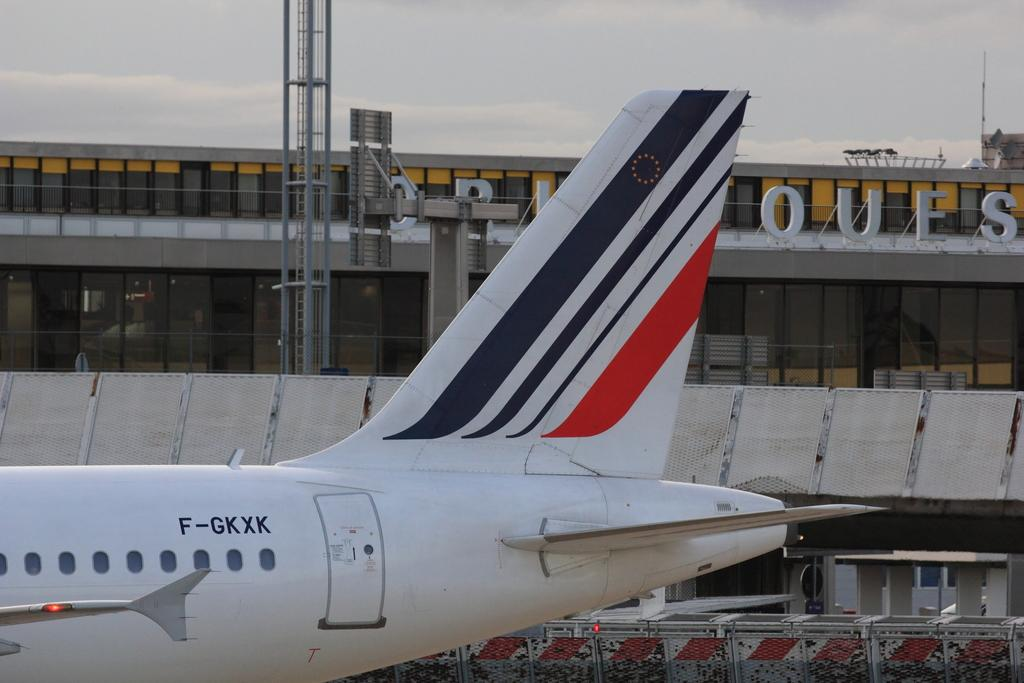What type of location might the image have been taken at? The image might have been taken at an airport. What can be seen at the top of the image? There is sky visible at the top of the image. What is located at the bottom of the image? There is an airplane at the bottom of the image. What features does the airplane have? The airplane has wings and windows. What type of whistle can be heard in the image? There is no whistle present in the image, and therefore no sound can be heard. What type of apparel is the airplane wearing in the image? Airplanes do not wear apparel; they are inanimate objects. --- Facts: 1. There is a person sitting on a bench in the image. 2. The person is reading a book. 3. There is a tree behind the bench. 4. The sky is visible in the background. 5. The person is wearing a hat. Absurd Topics: dance, ocean, sculpture Conversation: What is the person in the image doing? The person is sitting on a bench in the image. What activity is the person engaged in while sitting on the bench? The person is reading a book. What can be seen behind the bench in the image? There is a tree behind the bench. What is visible in the background of the image? The sky is visible in the background. What type of headwear is the person wearing? The person is wearing a hat. Reasoning: Let's think step by step in order to produce the conversation. We start by identifying the main subject in the image, which is the person sitting on the bench. Then, we describe the activity the person is engaged in, which is reading a book. Next, we mention the objects and features visible in the background, such as the tree and the sky. Finally, we focus on the person's attire, specifically the hat they are wearing. Absurd Question/Answer: What type of dance is the person performing in the image? There is no indication in the image that the person is dancing, as they are sitting on a bench and reading a book. Can you see the ocean in the image? No, the image does not show the ocean; it features a person sitting on a bench, a tree, and the sky. 